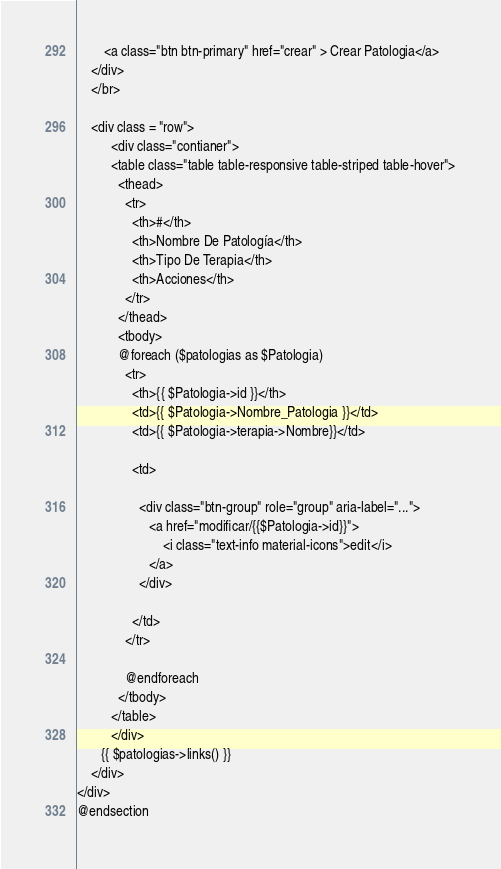<code> <loc_0><loc_0><loc_500><loc_500><_PHP_>        <a class="btn btn-primary" href="crear" > Crear Patologia</a>
    </div>
    </br>
    
    <div class = "row">
          <div class="contianer">
          <table class="table table-responsive table-striped table-hover">
            <thead>
              <tr>
                <th>#</th>
                <th>Nombre De Patología</th>
                <th>Tipo De Terapia</th>
                <th>Acciones</th>
              </tr>
            </thead>
            <tbody>
            @foreach ($patologias as $Patologia)
              <tr>
                <th>{{ $Patologia->id }}</th>
                <td>{{ $Patologia->Nombre_Patologia }}</td>
                <td>{{ $Patologia->terapia->Nombre}}</td>
                
                <td>

                  <div class="btn-group" role="group" aria-label="...">
                     <a href="modificar/{{$Patologia->id}}">
                         <i class="text-info material-icons">edit</i>
                     </a>
                  </div>

                </td>
              </tr>
              
              @endforeach
            </tbody>
          </table>
          </div>
       {{ $patologias->links() }} 
    </div>
</div>
@endsection</code> 